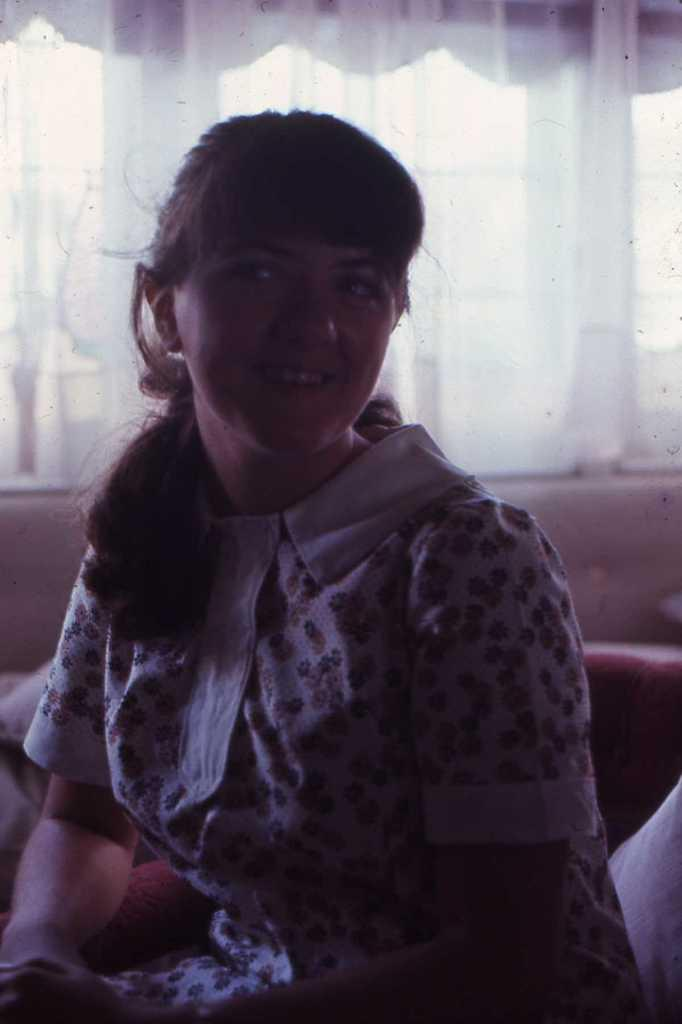Where was the image taken? The image was taken indoors. What can be seen in the background of the image? There is a wall with windows and curtains in the background. What is the girl in the image doing? The girl is sitting on the couch in the middle of the image. Is there a maid in the image helping the girl with her chores? There is no maid present in the image. What type of rail can be seen in the image? There is no rail present in the image. 